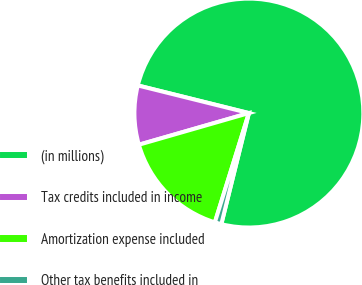Convert chart to OTSL. <chart><loc_0><loc_0><loc_500><loc_500><pie_chart><fcel>(in millions)<fcel>Tax credits included in income<fcel>Amortization expense included<fcel>Other tax benefits included in<nl><fcel>74.99%<fcel>8.34%<fcel>15.74%<fcel>0.93%<nl></chart> 